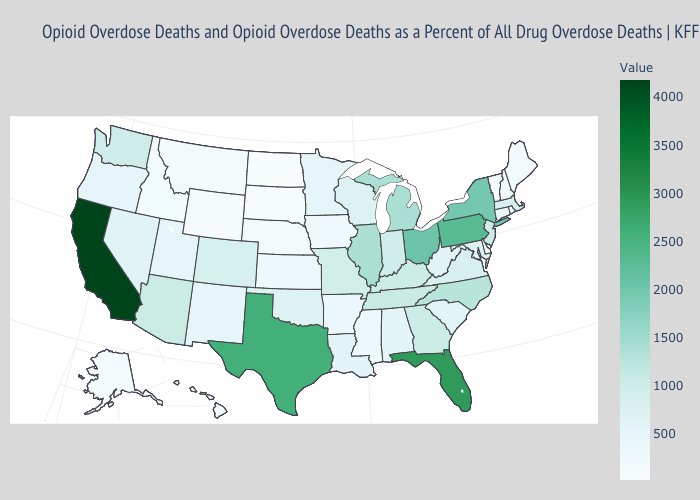Is the legend a continuous bar?
Write a very short answer. Yes. Does New Jersey have the highest value in the USA?
Give a very brief answer. No. Which states have the highest value in the USA?
Concise answer only. California. Which states have the lowest value in the USA?
Answer briefly. North Dakota. 